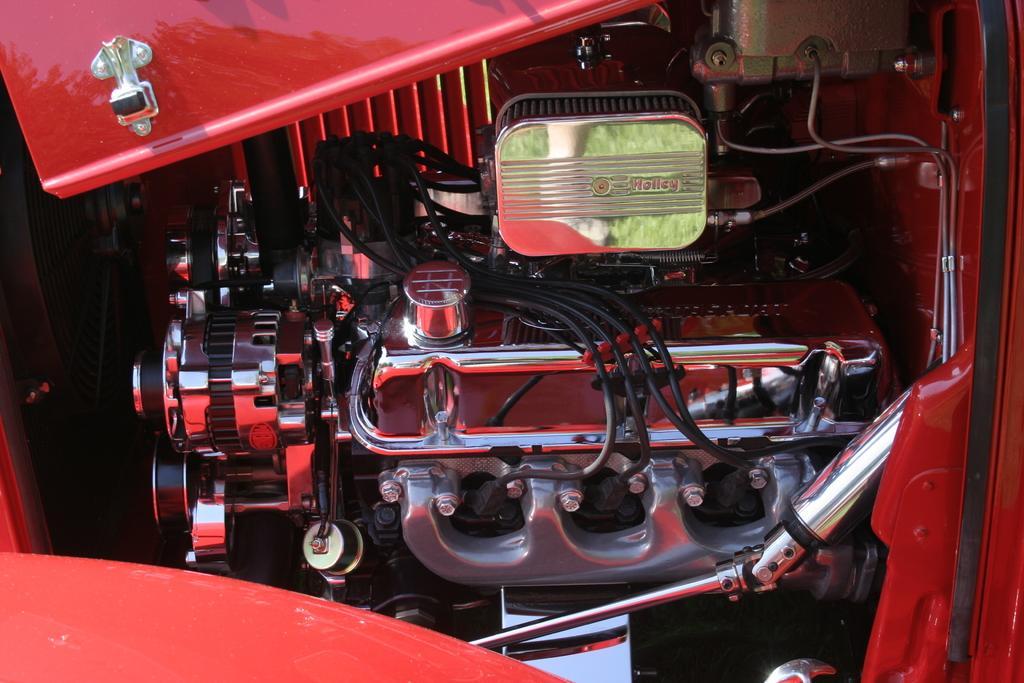Can you describe this image briefly? In this picture we can see wires, engine and other parts of a vehicle. 